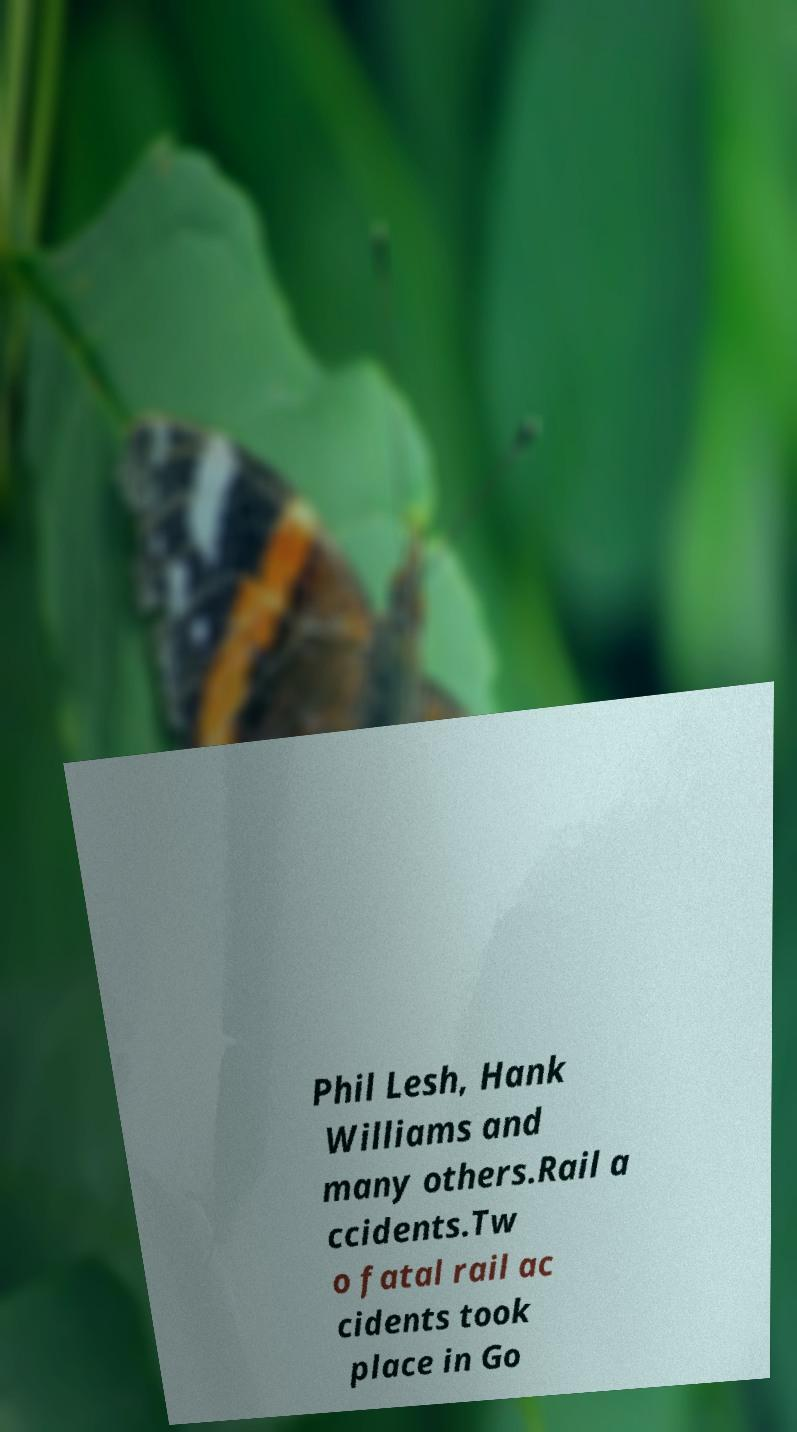What messages or text are displayed in this image? I need them in a readable, typed format. Phil Lesh, Hank Williams and many others.Rail a ccidents.Tw o fatal rail ac cidents took place in Go 